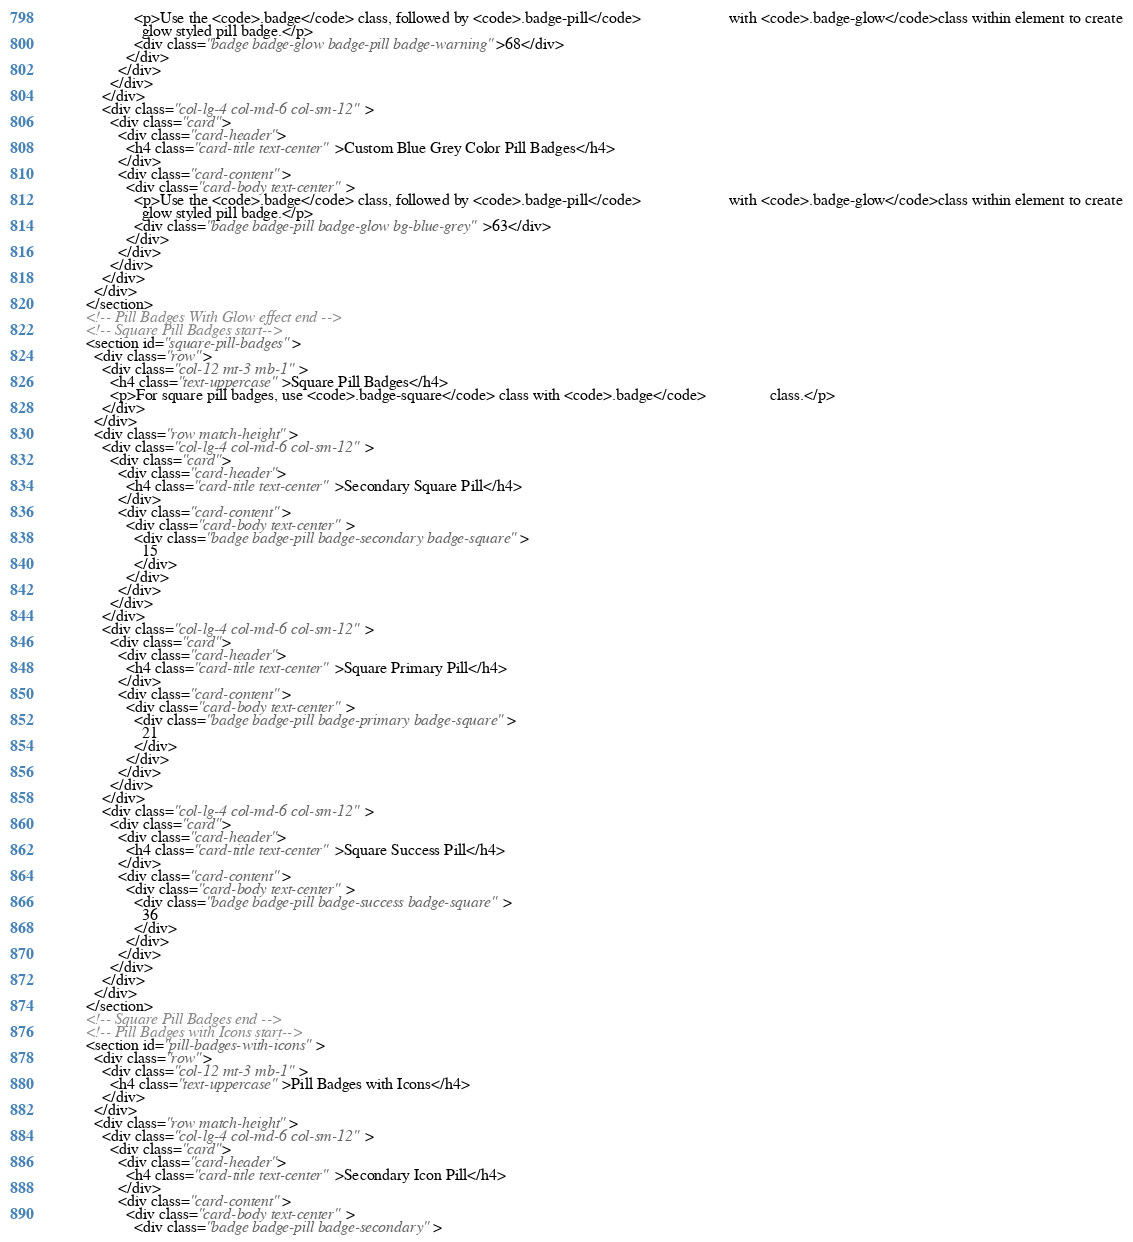<code> <loc_0><loc_0><loc_500><loc_500><_HTML_>                    <p>Use the <code>.badge</code> class, followed by <code>.badge-pill</code>                      with <code>.badge-glow</code>class within element to create
                      glow styled pill badge.</p>
                    <div class="badge badge-glow badge-pill badge-warning">68</div>
                  </div>
                </div>
              </div>
            </div>
            <div class="col-lg-4 col-md-6 col-sm-12">
              <div class="card">
                <div class="card-header">
                  <h4 class="card-title text-center">Custom Blue Grey Color Pill Badges</h4>
                </div>
                <div class="card-content">
                  <div class="card-body text-center">
                    <p>Use the <code>.badge</code> class, followed by <code>.badge-pill</code>                      with <code>.badge-glow</code>class within element to create
                      glow styled pill badge.</p>
                    <div class="badge badge-pill badge-glow bg-blue-grey">63</div>
                  </div>
                </div>
              </div>
            </div>
          </div>
        </section>
        <!-- Pill Badges With Glow effect end -->
        <!-- Square Pill Badges start-->
        <section id="square-pill-badges">
          <div class="row">
            <div class="col-12 mt-3 mb-1">
              <h4 class="text-uppercase">Square Pill Badges</h4>
              <p>For square pill badges, use <code>.badge-square</code> class with <code>.badge</code>                class.</p>
            </div>
          </div>
          <div class="row match-height">
            <div class="col-lg-4 col-md-6 col-sm-12">
              <div class="card">
                <div class="card-header">
                  <h4 class="card-title text-center">Secondary Square Pill</h4>
                </div>
                <div class="card-content">
                  <div class="card-body text-center">
                    <div class="badge badge-pill badge-secondary badge-square">
                      15
                    </div>
                  </div>
                </div>
              </div>
            </div>
            <div class="col-lg-4 col-md-6 col-sm-12">
              <div class="card">
                <div class="card-header">
                  <h4 class="card-title text-center">Square Primary Pill</h4>
                </div>
                <div class="card-content">
                  <div class="card-body text-center">
                    <div class="badge badge-pill badge-primary badge-square">
                      21
                    </div>
                  </div>
                </div>
              </div>
            </div>
            <div class="col-lg-4 col-md-6 col-sm-12">
              <div class="card">
                <div class="card-header">
                  <h4 class="card-title text-center">Square Success Pill</h4>
                </div>
                <div class="card-content">
                  <div class="card-body text-center">
                    <div class="badge badge-pill badge-success badge-square">
                      36
                    </div>
                  </div>
                </div>
              </div>
            </div>
          </div>
        </section>
        <!-- Square Pill Badges end -->
        <!-- Pill Badges with Icons start-->
        <section id="pill-badges-with-icons">
          <div class="row">
            <div class="col-12 mt-3 mb-1">
              <h4 class="text-uppercase">Pill Badges with Icons</h4>
            </div>
          </div>
          <div class="row match-height">
            <div class="col-lg-4 col-md-6 col-sm-12">
              <div class="card">
                <div class="card-header">
                  <h4 class="card-title text-center">Secondary Icon Pill</h4>
                </div>
                <div class="card-content">
                  <div class="card-body text-center">
                    <div class="badge badge-pill badge-secondary"></code> 